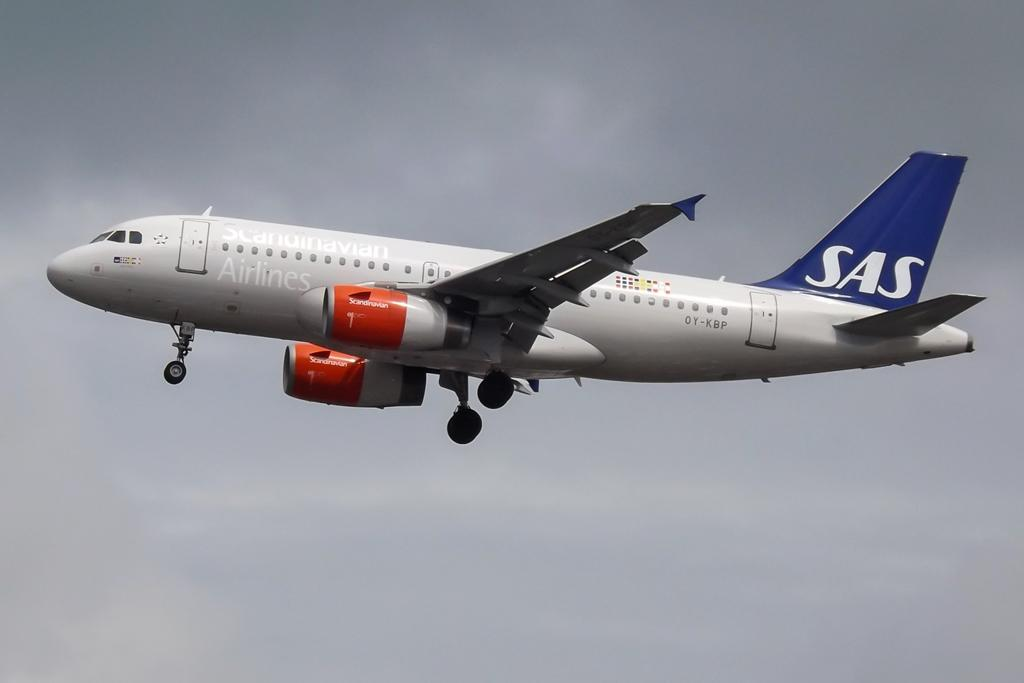<image>
Create a compact narrative representing the image presented. An airplane flying in the sky with SAS on the tail 